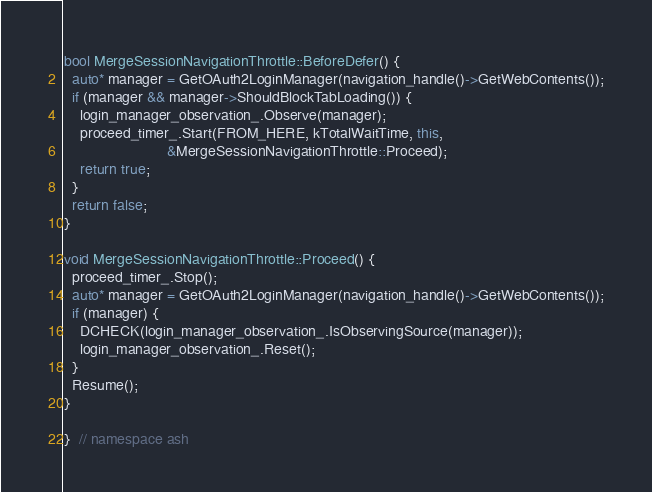Convert code to text. <code><loc_0><loc_0><loc_500><loc_500><_C++_>
bool MergeSessionNavigationThrottle::BeforeDefer() {
  auto* manager = GetOAuth2LoginManager(navigation_handle()->GetWebContents());
  if (manager && manager->ShouldBlockTabLoading()) {
    login_manager_observation_.Observe(manager);
    proceed_timer_.Start(FROM_HERE, kTotalWaitTime, this,
                         &MergeSessionNavigationThrottle::Proceed);
    return true;
  }
  return false;
}

void MergeSessionNavigationThrottle::Proceed() {
  proceed_timer_.Stop();
  auto* manager = GetOAuth2LoginManager(navigation_handle()->GetWebContents());
  if (manager) {
    DCHECK(login_manager_observation_.IsObservingSource(manager));
    login_manager_observation_.Reset();
  }
  Resume();
}

}  // namespace ash
</code> 